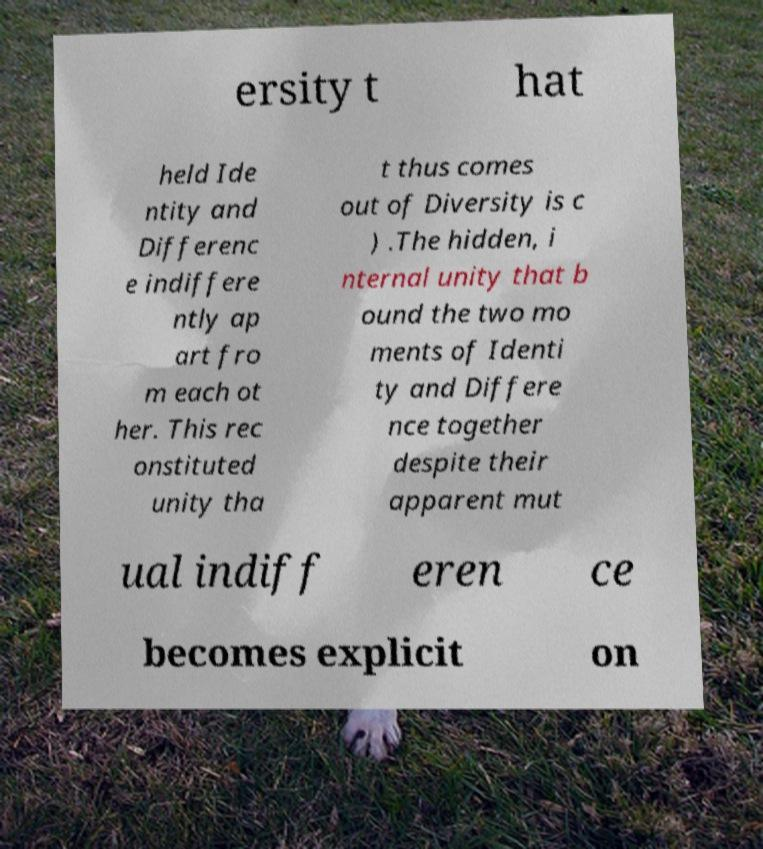I need the written content from this picture converted into text. Can you do that? ersity t hat held Ide ntity and Differenc e indiffere ntly ap art fro m each ot her. This rec onstituted unity tha t thus comes out of Diversity is c ) .The hidden, i nternal unity that b ound the two mo ments of Identi ty and Differe nce together despite their apparent mut ual indiff eren ce becomes explicit on 